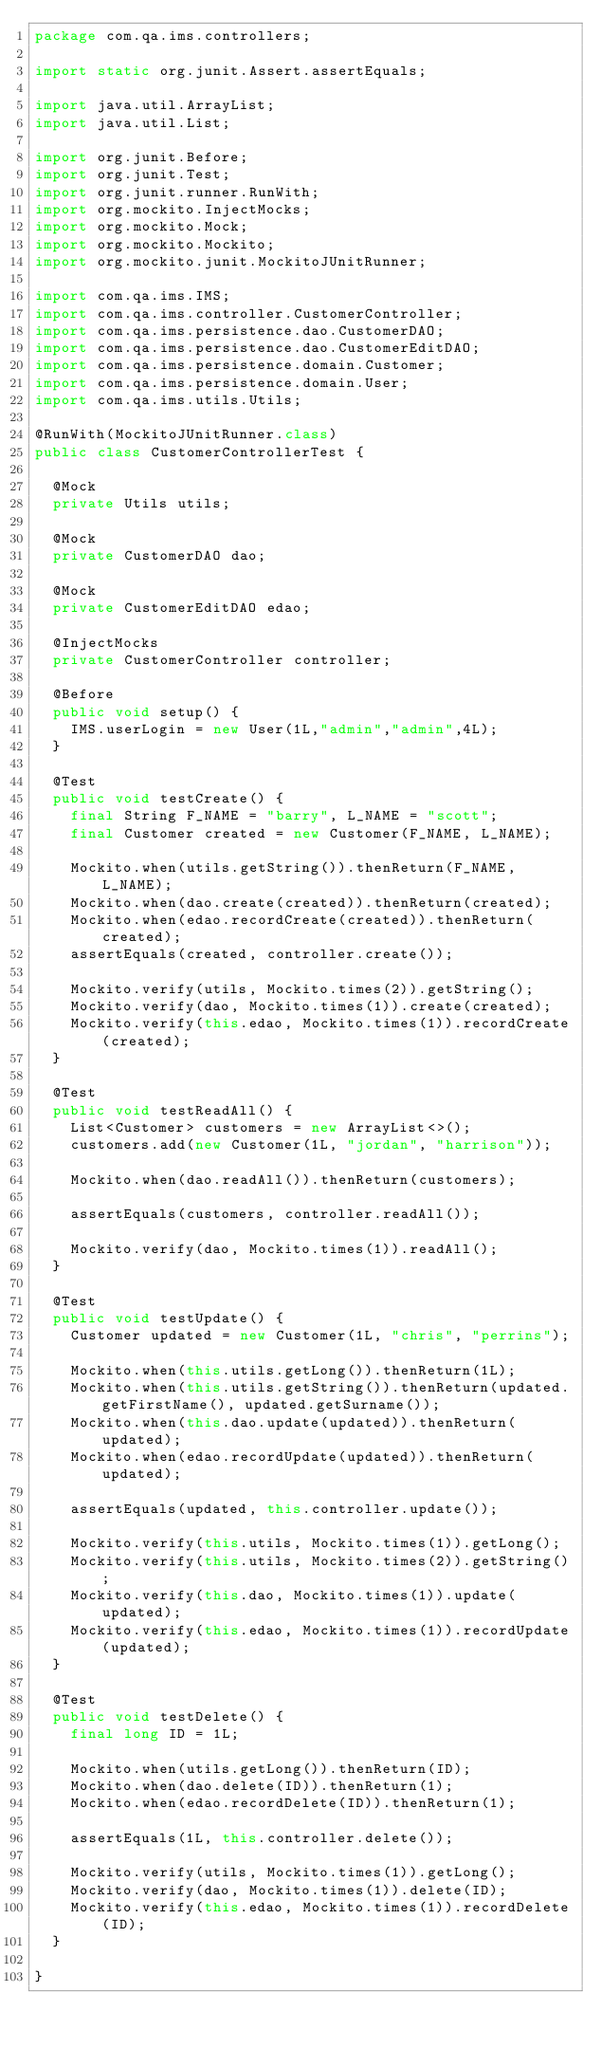<code> <loc_0><loc_0><loc_500><loc_500><_Java_>package com.qa.ims.controllers;

import static org.junit.Assert.assertEquals;

import java.util.ArrayList;
import java.util.List;

import org.junit.Before;
import org.junit.Test;
import org.junit.runner.RunWith;
import org.mockito.InjectMocks;
import org.mockito.Mock;
import org.mockito.Mockito;
import org.mockito.junit.MockitoJUnitRunner;

import com.qa.ims.IMS;
import com.qa.ims.controller.CustomerController;
import com.qa.ims.persistence.dao.CustomerDAO;
import com.qa.ims.persistence.dao.CustomerEditDAO;
import com.qa.ims.persistence.domain.Customer;
import com.qa.ims.persistence.domain.User;
import com.qa.ims.utils.Utils;

@RunWith(MockitoJUnitRunner.class)
public class CustomerControllerTest {

	@Mock
	private Utils utils;

	@Mock
	private CustomerDAO dao;
	
	@Mock
	private CustomerEditDAO edao;
	
	@InjectMocks
	private CustomerController controller;

	@Before
	public void setup() {
		IMS.userLogin = new User(1L,"admin","admin",4L);
	}
	
	@Test
	public void testCreate() {
		final String F_NAME = "barry", L_NAME = "scott";
		final Customer created = new Customer(F_NAME, L_NAME);

		Mockito.when(utils.getString()).thenReturn(F_NAME, L_NAME);
		Mockito.when(dao.create(created)).thenReturn(created);
		Mockito.when(edao.recordCreate(created)).thenReturn(created);
		assertEquals(created, controller.create());

		Mockito.verify(utils, Mockito.times(2)).getString();
		Mockito.verify(dao, Mockito.times(1)).create(created);
		Mockito.verify(this.edao, Mockito.times(1)).recordCreate(created);
	}

	@Test
	public void testReadAll() {
		List<Customer> customers = new ArrayList<>();
		customers.add(new Customer(1L, "jordan", "harrison"));

		Mockito.when(dao.readAll()).thenReturn(customers);

		assertEquals(customers, controller.readAll());

		Mockito.verify(dao, Mockito.times(1)).readAll();
	}

	@Test
	public void testUpdate() {
		Customer updated = new Customer(1L, "chris", "perrins");

		Mockito.when(this.utils.getLong()).thenReturn(1L);
		Mockito.when(this.utils.getString()).thenReturn(updated.getFirstName(), updated.getSurname());
		Mockito.when(this.dao.update(updated)).thenReturn(updated);
		Mockito.when(edao.recordUpdate(updated)).thenReturn(updated);

		assertEquals(updated, this.controller.update());

		Mockito.verify(this.utils, Mockito.times(1)).getLong();
		Mockito.verify(this.utils, Mockito.times(2)).getString();
		Mockito.verify(this.dao, Mockito.times(1)).update(updated);
		Mockito.verify(this.edao, Mockito.times(1)).recordUpdate(updated);
	}

	@Test
	public void testDelete() {
		final long ID = 1L;

		Mockito.when(utils.getLong()).thenReturn(ID);
		Mockito.when(dao.delete(ID)).thenReturn(1);
		Mockito.when(edao.recordDelete(ID)).thenReturn(1);

		assertEquals(1L, this.controller.delete());

		Mockito.verify(utils, Mockito.times(1)).getLong();
		Mockito.verify(dao, Mockito.times(1)).delete(ID);
		Mockito.verify(this.edao, Mockito.times(1)).recordDelete(ID);
	}

}
</code> 